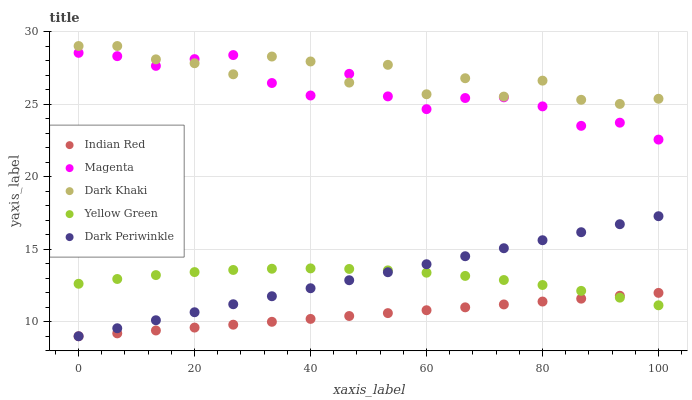Does Indian Red have the minimum area under the curve?
Answer yes or no. Yes. Does Dark Khaki have the maximum area under the curve?
Answer yes or no. Yes. Does Magenta have the minimum area under the curve?
Answer yes or no. No. Does Magenta have the maximum area under the curve?
Answer yes or no. No. Is Dark Periwinkle the smoothest?
Answer yes or no. Yes. Is Dark Khaki the roughest?
Answer yes or no. Yes. Is Magenta the smoothest?
Answer yes or no. No. Is Magenta the roughest?
Answer yes or no. No. Does Indian Red have the lowest value?
Answer yes or no. Yes. Does Magenta have the lowest value?
Answer yes or no. No. Does Dark Khaki have the highest value?
Answer yes or no. Yes. Does Magenta have the highest value?
Answer yes or no. No. Is Dark Periwinkle less than Dark Khaki?
Answer yes or no. Yes. Is Dark Khaki greater than Dark Periwinkle?
Answer yes or no. Yes. Does Magenta intersect Dark Khaki?
Answer yes or no. Yes. Is Magenta less than Dark Khaki?
Answer yes or no. No. Is Magenta greater than Dark Khaki?
Answer yes or no. No. Does Dark Periwinkle intersect Dark Khaki?
Answer yes or no. No. 